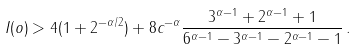Convert formula to latex. <formula><loc_0><loc_0><loc_500><loc_500>I ( o ) > 4 ( 1 + 2 ^ { - \alpha / 2 } ) + 8 c ^ { - \alpha } \frac { 3 ^ { \alpha - 1 } + 2 ^ { \alpha - 1 } + 1 } { 6 ^ { \alpha - 1 } - 3 ^ { \alpha - 1 } - 2 ^ { \alpha - 1 } - 1 } \, .</formula> 